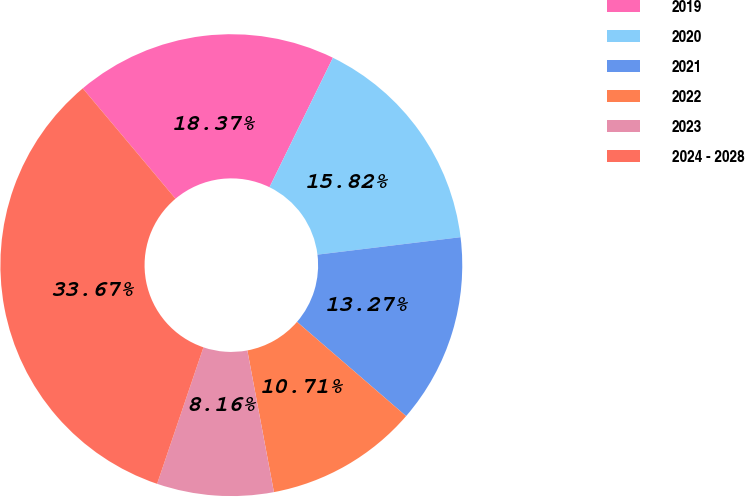<chart> <loc_0><loc_0><loc_500><loc_500><pie_chart><fcel>2019<fcel>2020<fcel>2021<fcel>2022<fcel>2023<fcel>2024 - 2028<nl><fcel>18.37%<fcel>15.82%<fcel>13.27%<fcel>10.71%<fcel>8.16%<fcel>33.67%<nl></chart> 